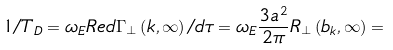<formula> <loc_0><loc_0><loc_500><loc_500>1 / T _ { D } = \omega _ { E } R e d \Gamma _ { \bot } \left ( { k , \infty } \right ) / d \tau = \omega _ { E } \frac { { 3 a ^ { 2 } } } { 2 \pi } R _ { \bot } \left ( { b _ { k } , \infty } \right ) =</formula> 